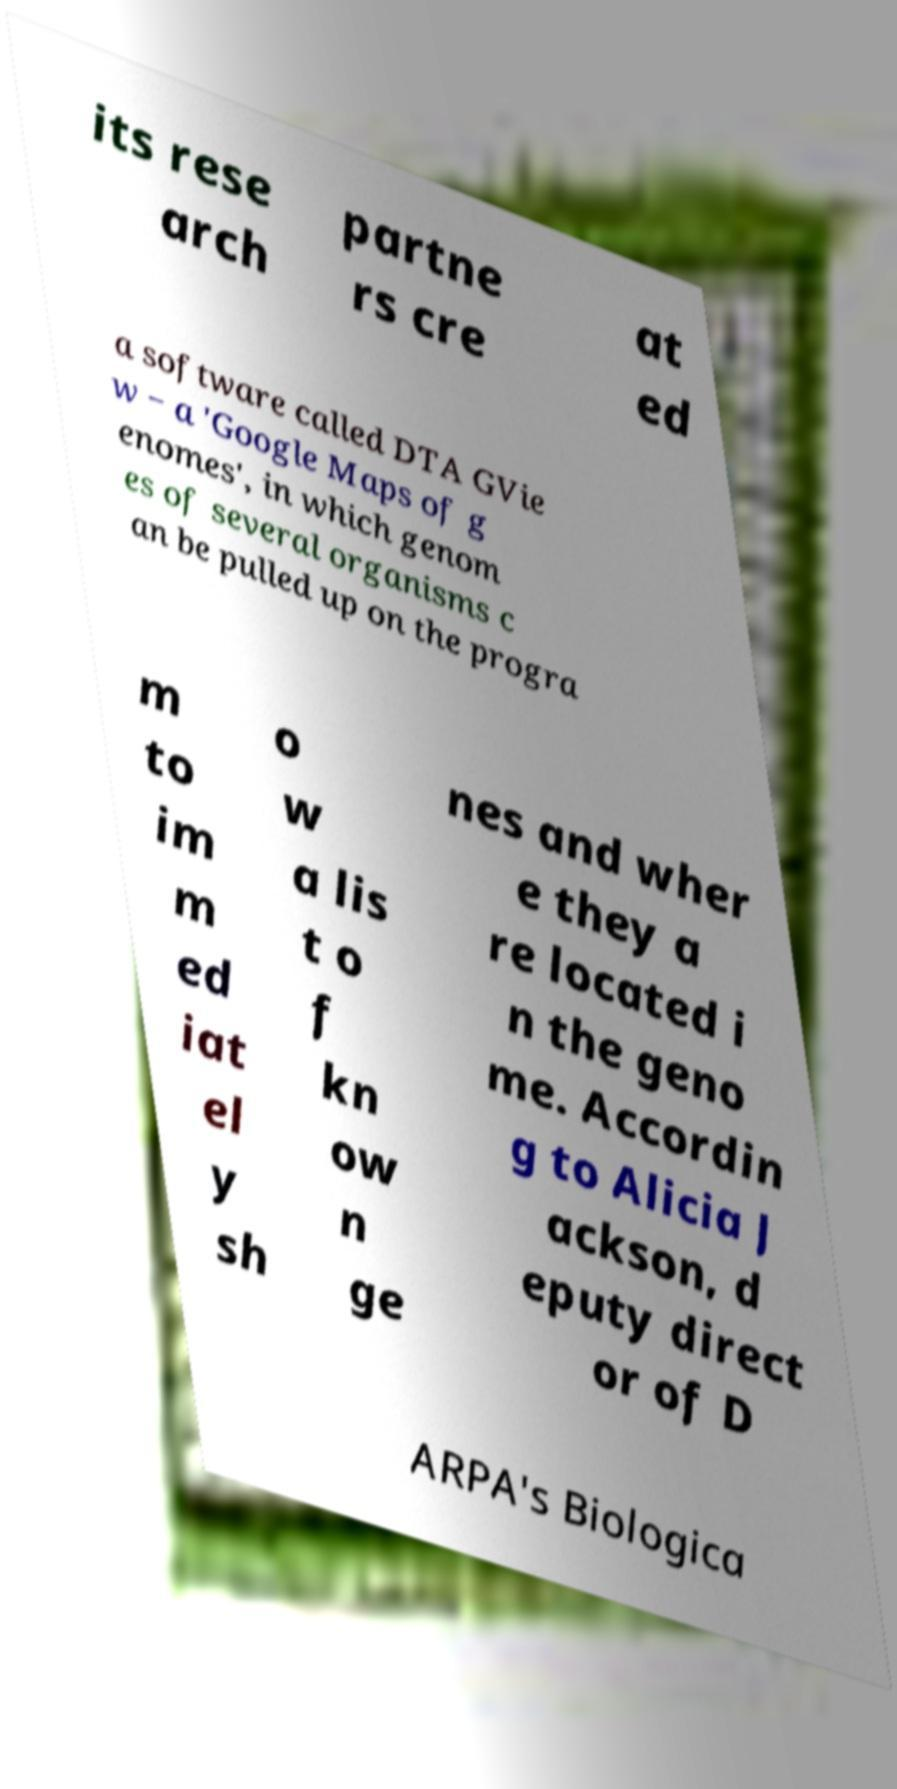Please read and relay the text visible in this image. What does it say? its rese arch partne rs cre at ed a software called DTA GVie w − a 'Google Maps of g enomes', in which genom es of several organisms c an be pulled up on the progra m to im m ed iat el y sh o w a lis t o f kn ow n ge nes and wher e they a re located i n the geno me. Accordin g to Alicia J ackson, d eputy direct or of D ARPA's Biologica 